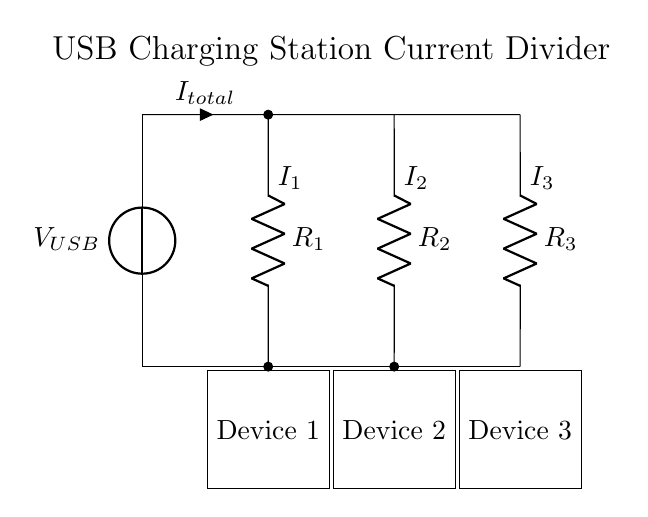What is the total current flowing in this circuit? The total current flowing is labeled as I total in the circuit diagram, which represents the sum of the individual branch currents (I1, I2, I3).
Answer: I total What are the resistances of the connected devices? The resistances are given as R1, R2, and R3 in the diagram, representing the devices connected in parallel across the USB charging station.
Answer: R1, R2, R3 In which direction does the current flow? The current flows from the top of the circuit (USB input) downward through the branches to the devices, indicated by the arrows for currents I1, I2, and I3.
Answer: Downward How does the current divide among the devices? The total current from the USB source divides among the parallel branches according to the values of the respective resistances R1, R2, and R3, following the current divider rule which states that the current through each branch is inversely proportional to its resistance.
Answer: According to resistance values What is the total resistance seen by the USB source? The total resistance is calculated using the parallel resistance formula: 1/R total = 1/R1 + 1/R2 + 1/R3, where R total is the equivalent resistance of the circuit from the USB source's viewpoint.
Answer: R total = 1/(1/R1 + 1/R2 + 1/R3) Which device receives the highest current? The device with the lowest resistance receives the highest current due to the current divider effect, as current is inversely proportional to resistance in a parallel circuit.
Answer: Device with lowest resistance 